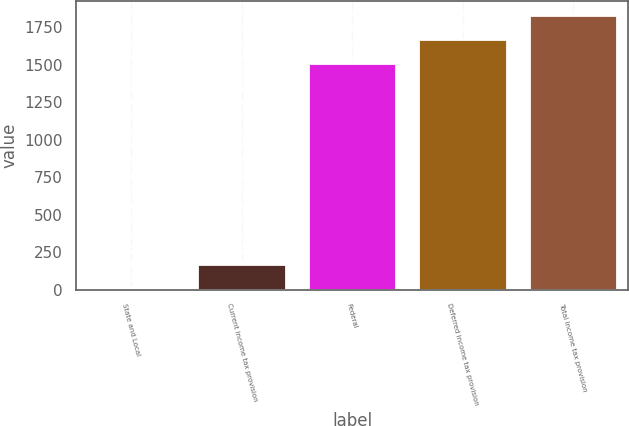<chart> <loc_0><loc_0><loc_500><loc_500><bar_chart><fcel>State and Local<fcel>Current income tax provision<fcel>Federal<fcel>Deferred income tax provision<fcel>Total income tax provision<nl><fcel>12<fcel>173.1<fcel>1508<fcel>1669.1<fcel>1830.2<nl></chart> 